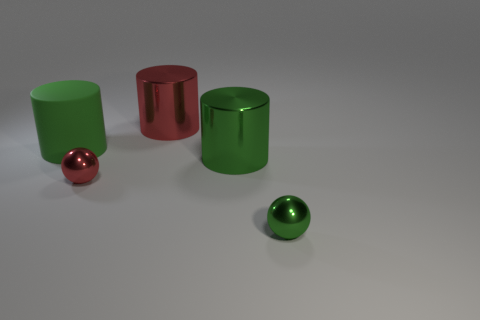Subtract all large matte cylinders. How many cylinders are left? 2 Add 1 small matte things. How many objects exist? 6 Subtract all cylinders. How many objects are left? 2 Subtract 2 cylinders. How many cylinders are left? 1 Add 1 green balls. How many green balls are left? 2 Add 3 spheres. How many spheres exist? 5 Subtract all red cylinders. How many cylinders are left? 2 Subtract 2 green cylinders. How many objects are left? 3 Subtract all gray balls. Subtract all blue cubes. How many balls are left? 2 Subtract all gray spheres. How many purple cylinders are left? 0 